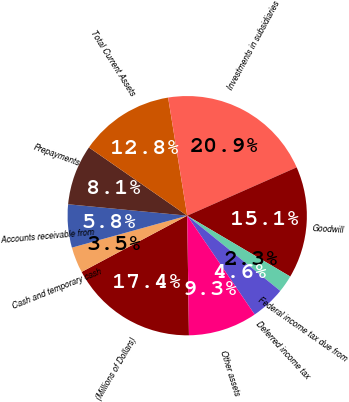Convert chart. <chart><loc_0><loc_0><loc_500><loc_500><pie_chart><fcel>(Millions of Dollars)<fcel>Cash and temporary cash<fcel>Accounts receivable from<fcel>Prepayments<fcel>Total Current Assets<fcel>Investments in subsidiaries<fcel>Goodwill<fcel>Federal income tax due from<fcel>Deferred income tax<fcel>Other assets<nl><fcel>17.44%<fcel>3.49%<fcel>5.82%<fcel>8.14%<fcel>12.79%<fcel>20.93%<fcel>15.11%<fcel>2.33%<fcel>4.65%<fcel>9.3%<nl></chart> 